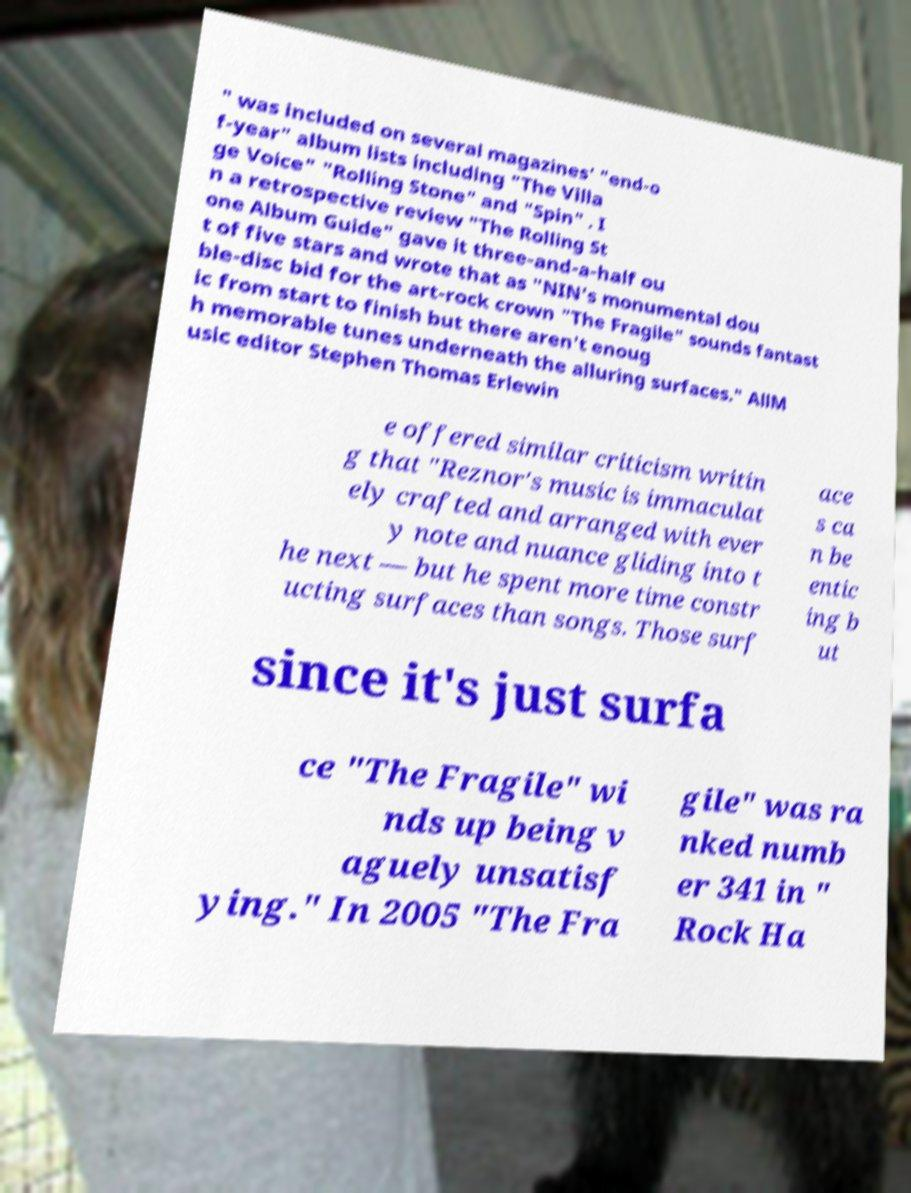Can you read and provide the text displayed in the image?This photo seems to have some interesting text. Can you extract and type it out for me? " was included on several magazines' "end-o f-year" album lists including "The Villa ge Voice" "Rolling Stone" and "Spin" . I n a retrospective review "The Rolling St one Album Guide" gave it three-and-a-half ou t of five stars and wrote that as "NIN's monumental dou ble-disc bid for the art-rock crown "The Fragile" sounds fantast ic from start to finish but there aren't enoug h memorable tunes underneath the alluring surfaces." AllM usic editor Stephen Thomas Erlewin e offered similar criticism writin g that "Reznor's music is immaculat ely crafted and arranged with ever y note and nuance gliding into t he next — but he spent more time constr ucting surfaces than songs. Those surf ace s ca n be entic ing b ut since it's just surfa ce "The Fragile" wi nds up being v aguely unsatisf ying." In 2005 "The Fra gile" was ra nked numb er 341 in " Rock Ha 